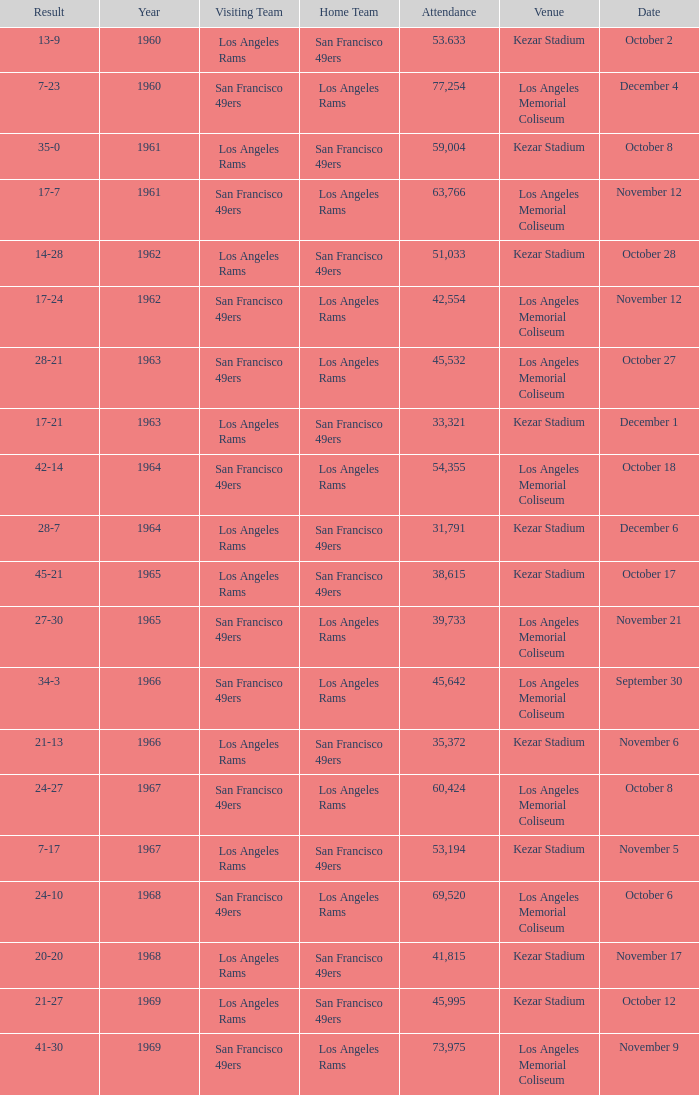Who is the home team when the san francisco 49ers are visiting with a result of 42-14? Los Angeles Rams. 